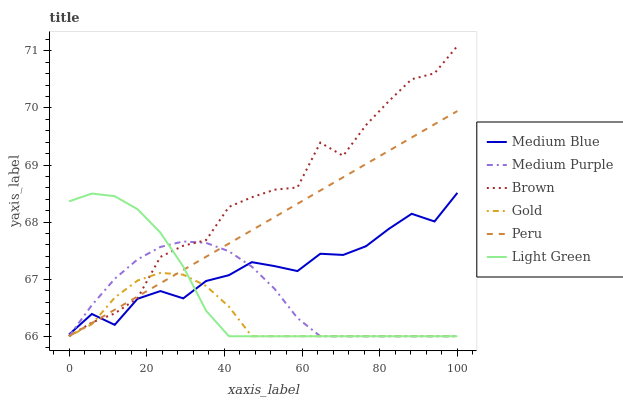Does Gold have the minimum area under the curve?
Answer yes or no. Yes. Does Brown have the maximum area under the curve?
Answer yes or no. Yes. Does Peru have the minimum area under the curve?
Answer yes or no. No. Does Peru have the maximum area under the curve?
Answer yes or no. No. Is Peru the smoothest?
Answer yes or no. Yes. Is Brown the roughest?
Answer yes or no. Yes. Is Gold the smoothest?
Answer yes or no. No. Is Gold the roughest?
Answer yes or no. No. Does Brown have the lowest value?
Answer yes or no. Yes. Does Medium Blue have the lowest value?
Answer yes or no. No. Does Brown have the highest value?
Answer yes or no. Yes. Does Peru have the highest value?
Answer yes or no. No. Does Gold intersect Medium Purple?
Answer yes or no. Yes. Is Gold less than Medium Purple?
Answer yes or no. No. Is Gold greater than Medium Purple?
Answer yes or no. No. 